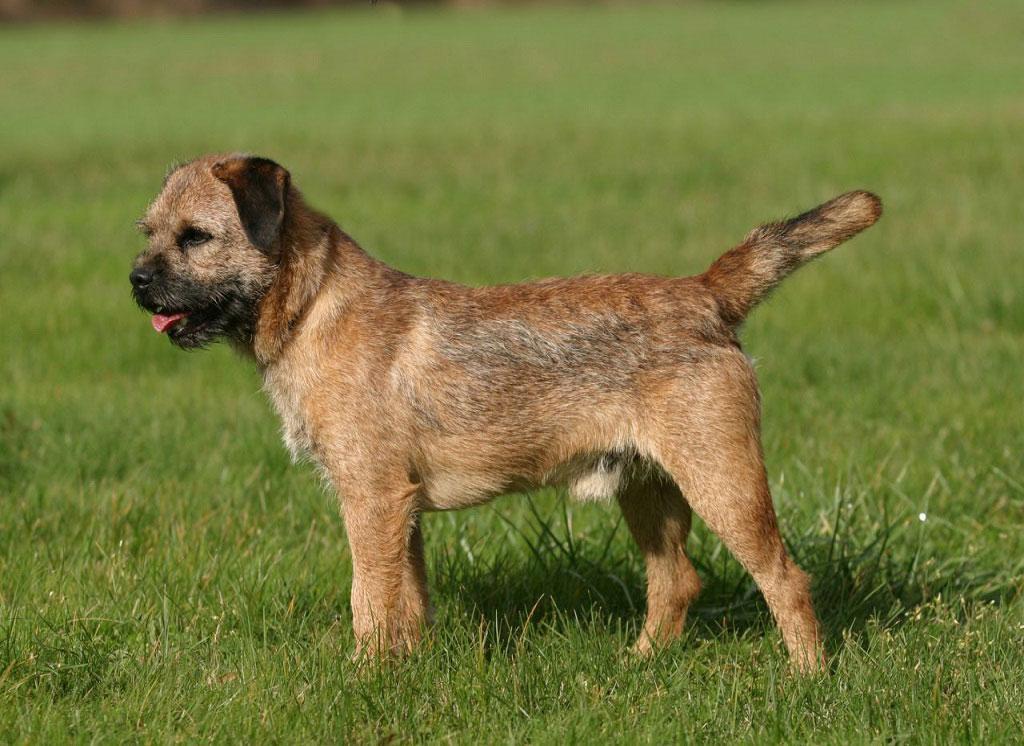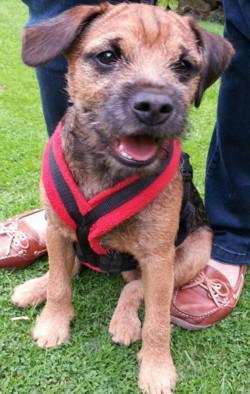The first image is the image on the left, the second image is the image on the right. For the images shown, is this caption "In both images, there's a border terrier sitting down." true? Answer yes or no. No. The first image is the image on the left, the second image is the image on the right. For the images displayed, is the sentence "There is a dog outside in the grass in the center of both of the images." factually correct? Answer yes or no. Yes. 